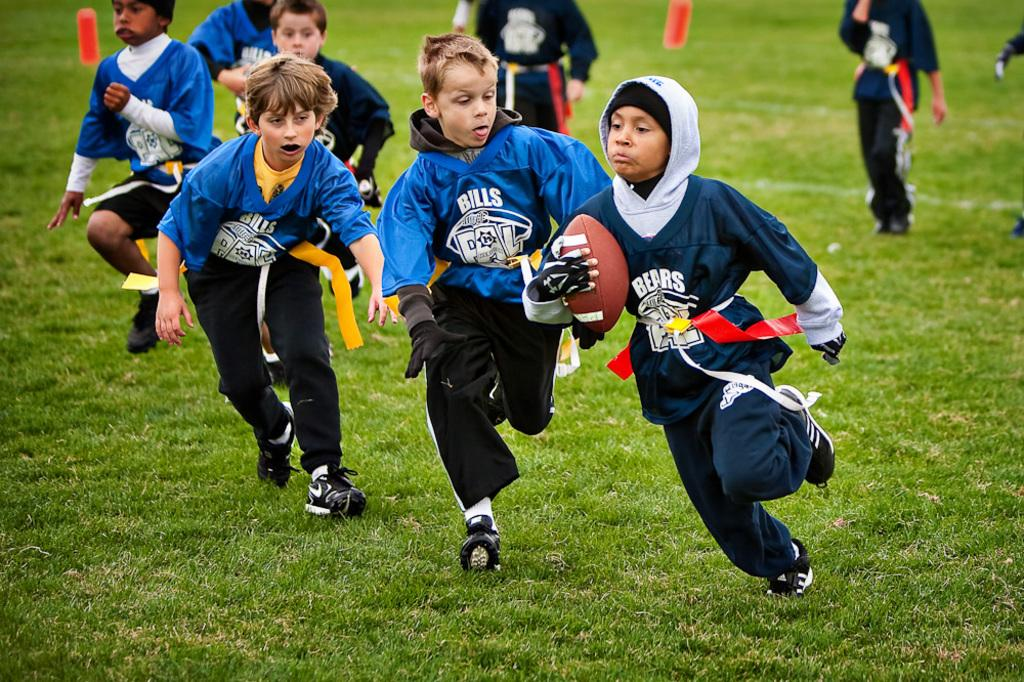<image>
Relay a brief, clear account of the picture shown. Youth football player in a blue jersey with Bills in white lettering on the front. 